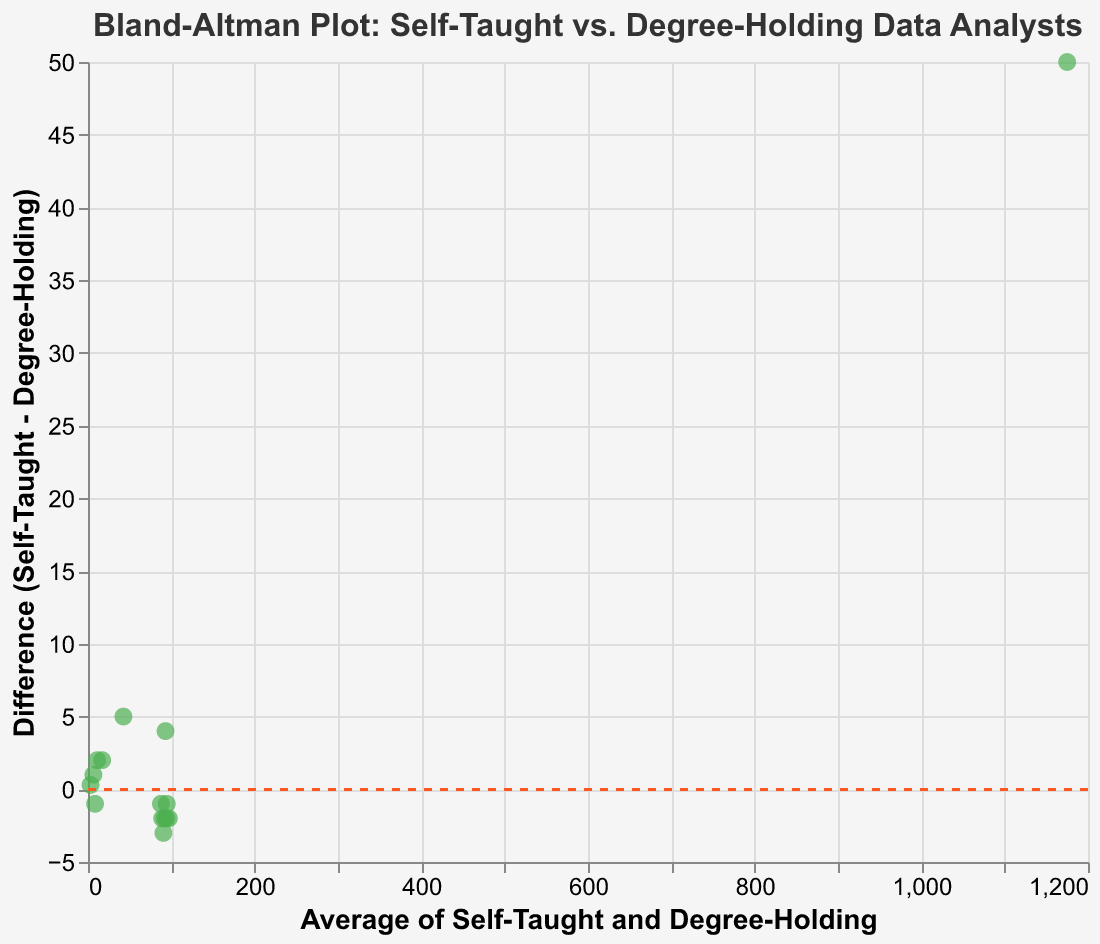What is the title of the Bland-Altman plot? The title is usually found at the top of the plot. It provides an overview of what the plot represents. Here, the title reads "Bland-Altman Plot: Self-Taught vs. Degree-Holding Data Analysts."
Answer: Bland-Altman Plot: Self-Taught vs. Degree-Holding Data Analysts What do the x-axis and y-axis represent in the plot? Each axis is labeled indicating what they represent. The x-axis represents "Average of Self-Taught and Degree-Holding," while the y-axis represents "Difference (Self-Taught - Degree-Holding)."
Answer: x-axis: Average of Self-Taught and Degree-Holding, y-axis: Difference (Self-Taught - Degree-Holding) How many data points are represented in the figure? Each dot in the figure corresponds to one measurement comparison, and by counting the dots, you can deduce the number of data points. There are 15 measurements in the data.
Answer: 15 Which measurement shows the largest difference between self-taught and degree-holding data analysts? Check the y-axis to find the point with the highest positive or negative value for "Difference (Self-Taught - Degree-Holding)." The measurements with the biggest differences are "NoSQL database query speed (ms)" and "Real-time analytics latency (seconds)," with differences of 5 ms and 0.3 seconds respectively. The largest among them is "NoSQL database query speed (ms)."
Answer: NoSQL database query speed (ms) What does the red dashed line in the plot signify? In a Bland-Altman plot, the red dashed line typically represents the mean difference, which is commonly set at 0. This line helps visualize whether the self-taught and degree-holding analysts differ systematically in their measurements.
Answer: Mean difference (usually zero) For "Dashboard creation time (hours)," what is the difference between self-taught and degree-holding data analysts? Find the point corresponding to "Dashboard creation time (hours)" and check its y-coordinate or calculate the difference directly from the data provided: Difference = Self-Taught (12) - Degree-Holding (10).
Answer: 2 hours Are there any metrics where self-taught data analysts performed better than degree-holding data analysts? Check for points above the red dashed line (y = 0), indicating that self-taught data analysts scored higher. Metrics where self-taught analysts performed better include "Data cleaning efficiency," "Dashboard creation time (hours)," "ETL pipeline throughput (records/min)," "Real-time analytics latency (seconds)," and "Data anomaly detection rate (%)."
Answer: Yes What is the average score for "Data cleaning efficiency" for both self-taught and degree-holding analysts? To find the average, take the values of both analysts for "Data cleaning efficiency" and calculate: (95 + 91) / 2.
Answer: 93 Which measurement shows the smallest difference between self-taught and degree-holding data analysts? Look for the point on the y-axis closest to the red dashed line (y = 0). The measurement with the smallest difference is "Machine learning model accuracy," with a difference of 1.
Answer: Machine learning model accuracy 